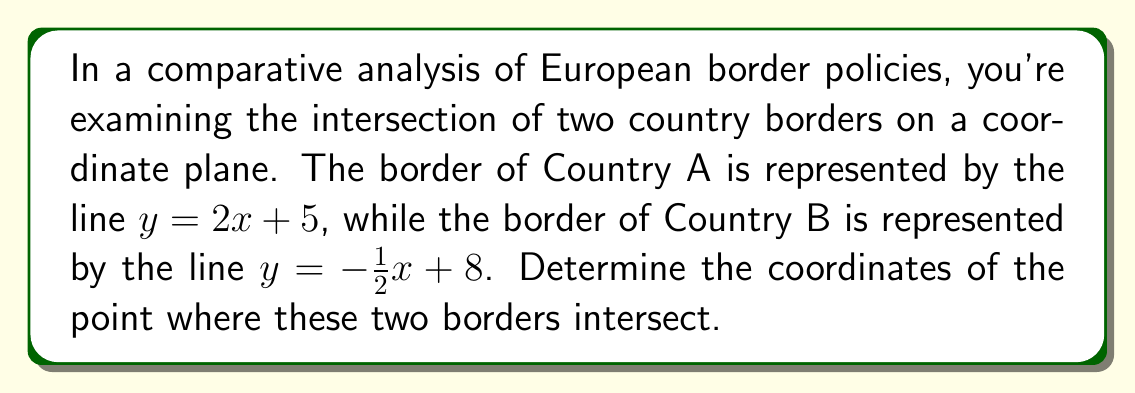Could you help me with this problem? To find the intersection point of the two border lines, we need to solve the system of equations:

1) $y = 2x + 5$ (Country A's border)
2) $y = -\frac{1}{2}x + 8$ (Country B's border)

At the intersection point, the y-coordinates will be equal. So we can set the right sides of these equations equal to each other:

3) $2x + 5 = -\frac{1}{2}x + 8$

Now, let's solve this equation for x:

4) $2x + \frac{1}{2}x = 8 - 5$
5) $\frac{5}{2}x = 3$
6) $x = \frac{3}{\frac{5}{2}} = \frac{3 \cdot 2}{5} = \frac{6}{5} = 1.2$

Now that we know the x-coordinate, we can substitute this value into either of the original equations to find the y-coordinate. Let's use Country A's equation:

7) $y = 2(1.2) + 5$
8) $y = 2.4 + 5 = 7.4$

Therefore, the intersection point has coordinates (1.2, 7.4).

To verify, we can substitute these coordinates into Country B's equation:

9) $7.4 = -\frac{1}{2}(1.2) + 8$
10) $7.4 = -0.6 + 8 = 7.4$

This confirms that our solution is correct.
Answer: (1.2, 7.4) 